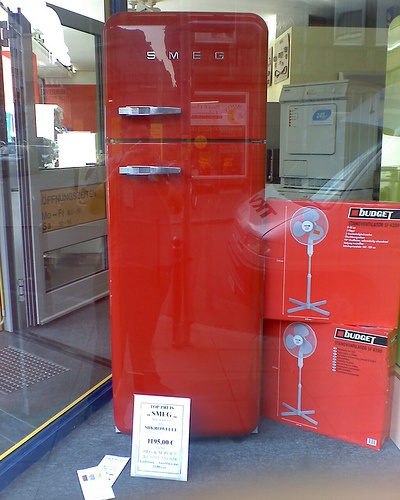Describe the objects in this image and their specific colors. I can see a refrigerator in lightgray, brown, and maroon tones in this image. 